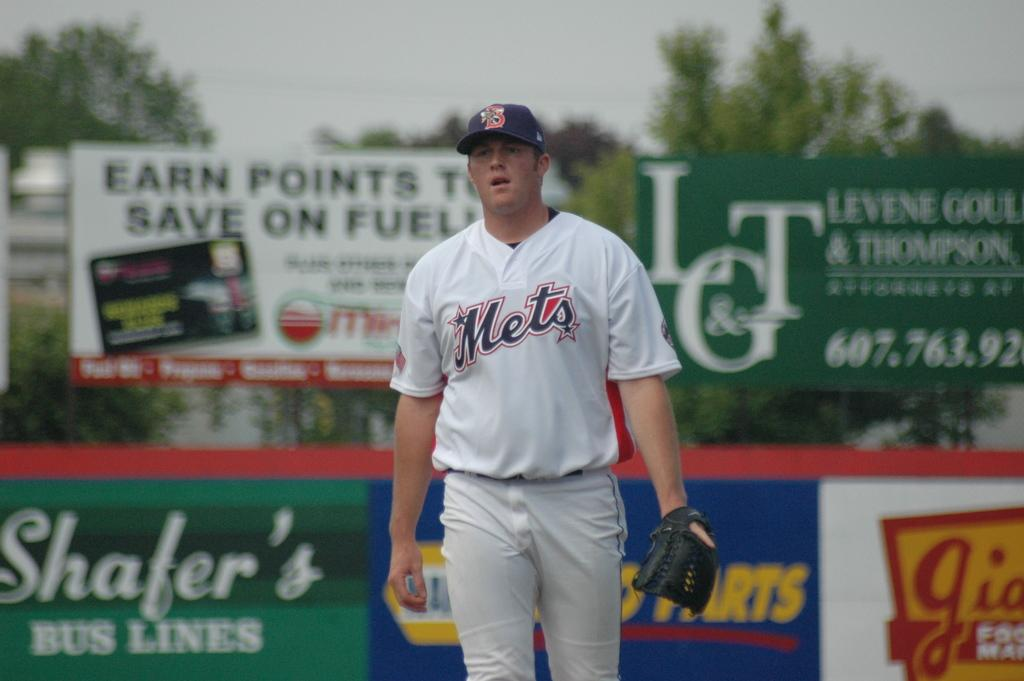<image>
Write a terse but informative summary of the picture. a Mets jersey with many ads in the background 